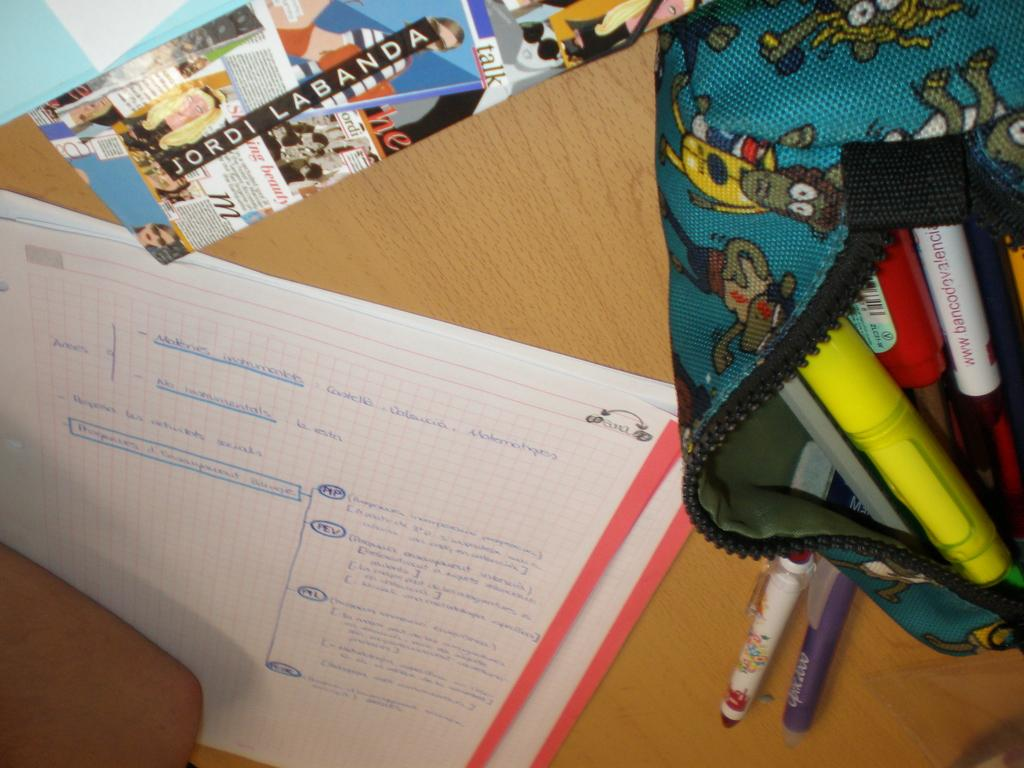<image>
Render a clear and concise summary of the photo. A piece of graph paper has the name Sara in the corner. 